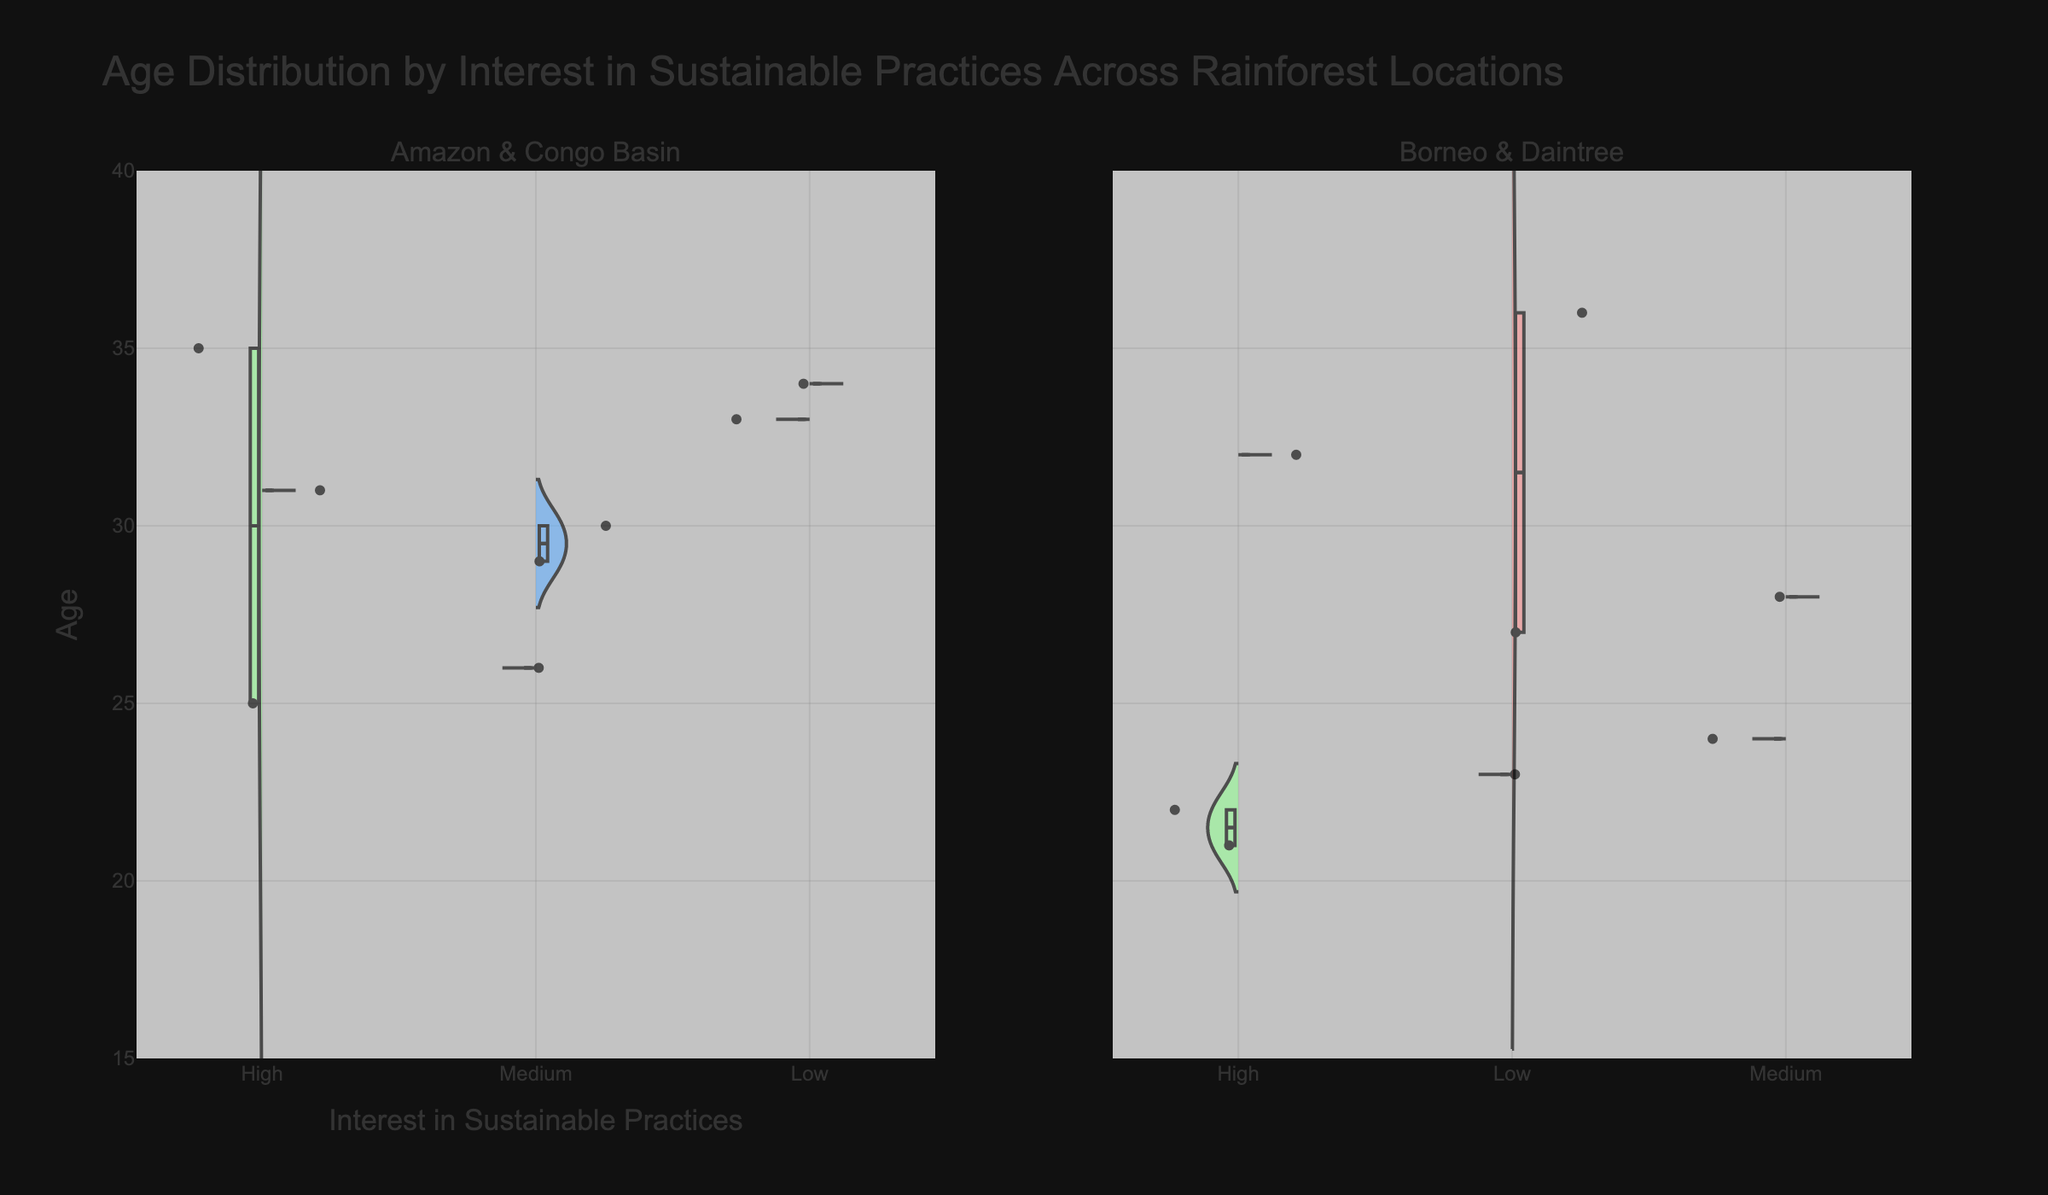what is the title of the split violin chart? The title is displayed at the top of the chart and it describes the overall content of the figure.
Answer: Age Distribution by Interest in Sustainable Practices Across Rainforest Locations What are the two locations compared on the left side? The subplot titles on the left side indicate the locations being compared.
Answer: Amazon & Congo Basin Which location has the lowest age with high interest in sustainable practices? Identify the location with the lowest age point among those with "High" interest in sustainable practices.
Answer: Borneo Rainforest How many different levels of interest in sustainable practices are shown? Count the distinct levels of interest in sustainable practices within the x-axis.
Answer: Three (Low, Medium, High) What is the age range covered in the figure? The range of the y-axis represents the age span covered by the data points.
Answer: 15 to 40 Which location has the most data points with low interest in sustainable practices? Observe the density and number of data points in the low-interest area for each location.
Answer: Congo Basin Among the Amazon Rainforest and Congo Basin, which location shows greater variability in age for those with medium interest in sustainable practices? Compare the spread of age values in the medium interest sections for both locations.
Answer: Amazon Rainforest What is the highest age with a medium level of interest shown for Daintree Rainforest? Identify the highest age data point within the "Medium" interest area for Daintree Rainforest.
Answer: 28 How does the age distribution compare between Amazon Rainforest and Congo Basin for those with high interest in sustainable practices? Compare the spreading and clustering of ages in the "High" interest sections for Amazon Rainforest and Congo Basin.
Answer: Amazon Rainforest has a wider age range What is the pattern of interest in sustainable practices for ages around 30 years in the Borneo Rainforest? Identify the level of interest commonly observed around the age of 30 in the Bornean plot.
Answer: Mainly Medium 